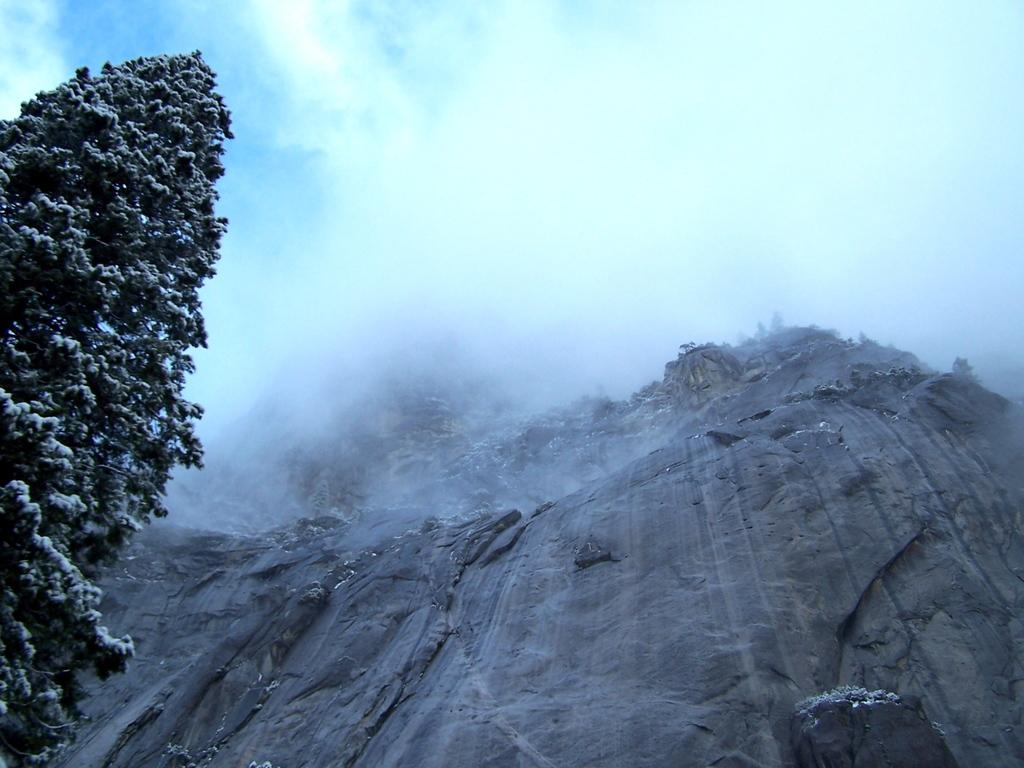What type of landscape feature is present in the image? There is a hill in the image. What type of vegetation can be seen in the image? There are trees in the image. What weather condition is depicted in the image? There is snow visible in the image. What type of sail can be seen on the hill in the image? There is no sail present in the image; it features a hill with trees and snow. 